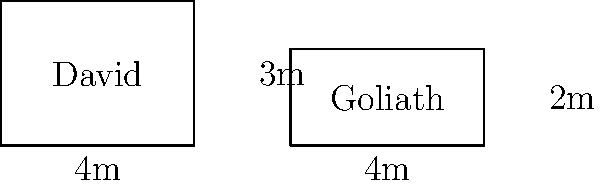David's sculptures of "David" and "Goliath" are represented by rectangles in the diagram. If the sculpture of David has a height of 3 meters and a width of 4 meters, while the sculpture of Goliath has a width of 4 meters and a height of 2 meters, what is the ratio of the area of David's sculpture to Goliath's sculpture? Let's approach this step-by-step:

1) First, we need to calculate the area of David's sculpture:
   Area of David = width × height
   $A_D = 4 \text{ m} \times 3 \text{ m} = 12 \text{ m}^2$

2) Next, we calculate the area of Goliath's sculpture:
   Area of Goliath = width × height
   $A_G = 4 \text{ m} \times 2 \text{ m} = 8 \text{ m}^2$

3) Now, we need to find the ratio of these areas:
   Ratio = Area of David : Area of Goliath
   $R = A_D : A_G = 12 : 8$

4) We can simplify this ratio by dividing both numbers by their greatest common divisor (4):
   $R = (12 \div 4) : (8 \div 4) = 3 : 2$

Therefore, the ratio of the area of David's sculpture to Goliath's sculpture is 3:2.
Answer: 3:2 